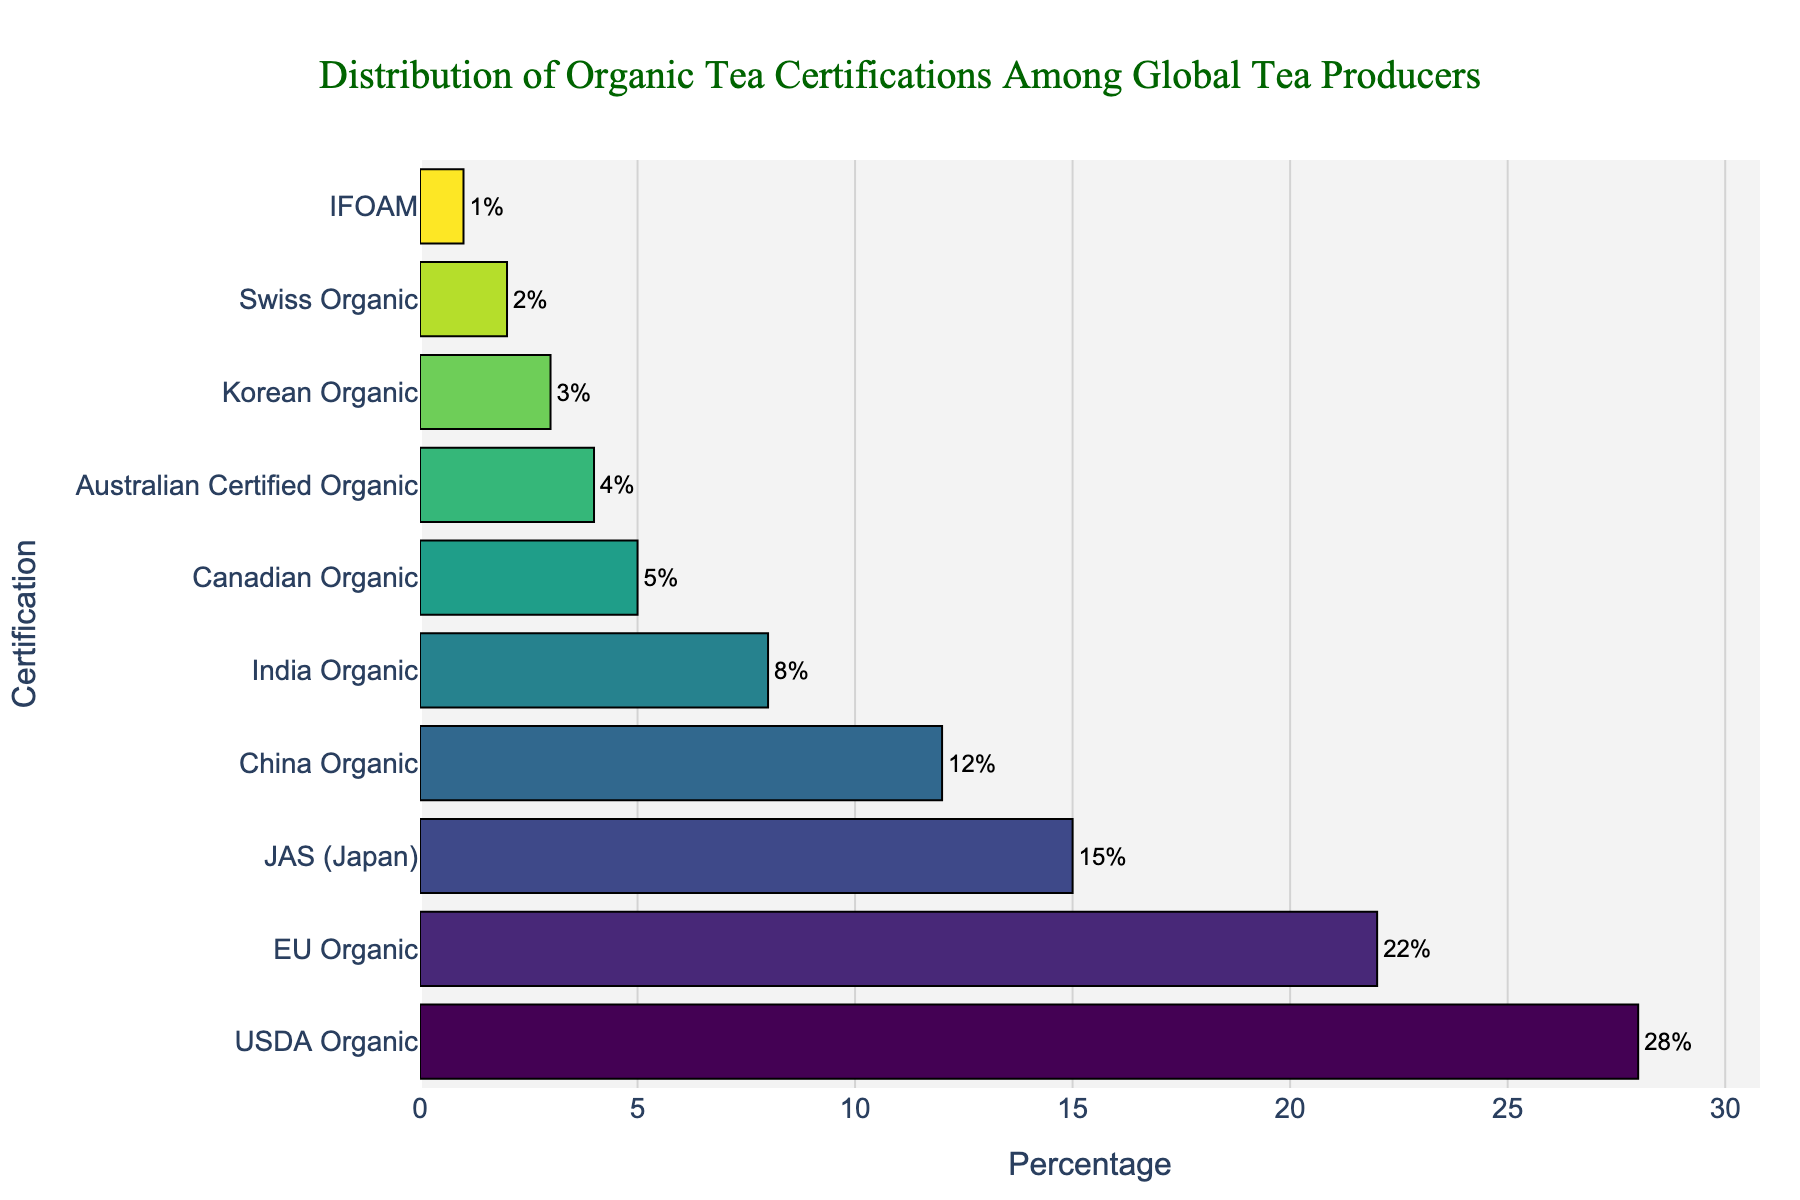How many certifications have a percentage greater than or equal to 10%? To find the number of certifications with a percentage greater than or equal to 10%, count the bars on the chart with values of 10% or more. Those are USDA Organic (28%), EU Organic (22%), JAS (Japan) (15%), and China Organic (12%).
Answer: 4 Which certification has the lowest percentage and what is it? Look at the bar with the smallest length at the bottom of the chart. The smallest percentage is 1%, corresponding to IFOAM.
Answer: IFOAM: 1% What is the percentage difference between USDA Organic and EU Organic? To find the difference, subtract the percentage of EU Organic (22%) from USDA Organic (28%): 28% - 22% = 6%.
Answer: 6% What is the sum of percentages for Australian Certified Organic, Korean Organic, Swiss Organic, and IFOAM? Sum the percentages of Australian Certified Organic (4%), Korean Organic (3%), Swiss Organic (2%), and IFOAM (1%): 4% + 3% + 2% + 1% = 10%.
Answer: 10% Which certifications have percentages between 5% and 15% inclusive? Identify and list certifications whose percentages fall within the 5%-15% range. These are JAS (Japan) (15%), China Organic (12%), and India Organic (8%), Canadian Organic (5%).
Answer: JAS (Japan), China Organic, India Organic, Canadian Organic Are there more certifications with percentages below or above 10%? Count the certifications with percentages below 10% and those with percentages above 10%. Below 10%: India Organic, Canadian Organic, Australian Certified Organic, Korean Organic, Swiss Organic, IFOAM (6 total). Above 10%: USDA Organic, EU Organic, JAS (Japan), and China Organic (4 total).
Answer: Below 10% What is the combined percentage of the top two certifications? The top two certifications are USDA Organic (28%) and EU Organic (22%). Adding their percentages yields: 28% + 22% = 50%.
Answer: 50% How does the percentage of Indian Organic certifications compare to that of Canadian Organic certifications? Compare the values directly from the chart: Indian Organic (8%), Canadian Organic (5%). India Organic has a higher percentage.
Answer: India Organic has a higher percentage Which certification lies exactly in the middle (median) when the certifications are sorted by their percentages? Sort certifications by their percentages. With 10 certifications, the middle ones are the 5th and 6th: India Organic (8%) and Canadian Organic (5%). The median is the average of these two: (8% + 5%) / 2 = 6.5%.
Answer: Median: 6.5% 